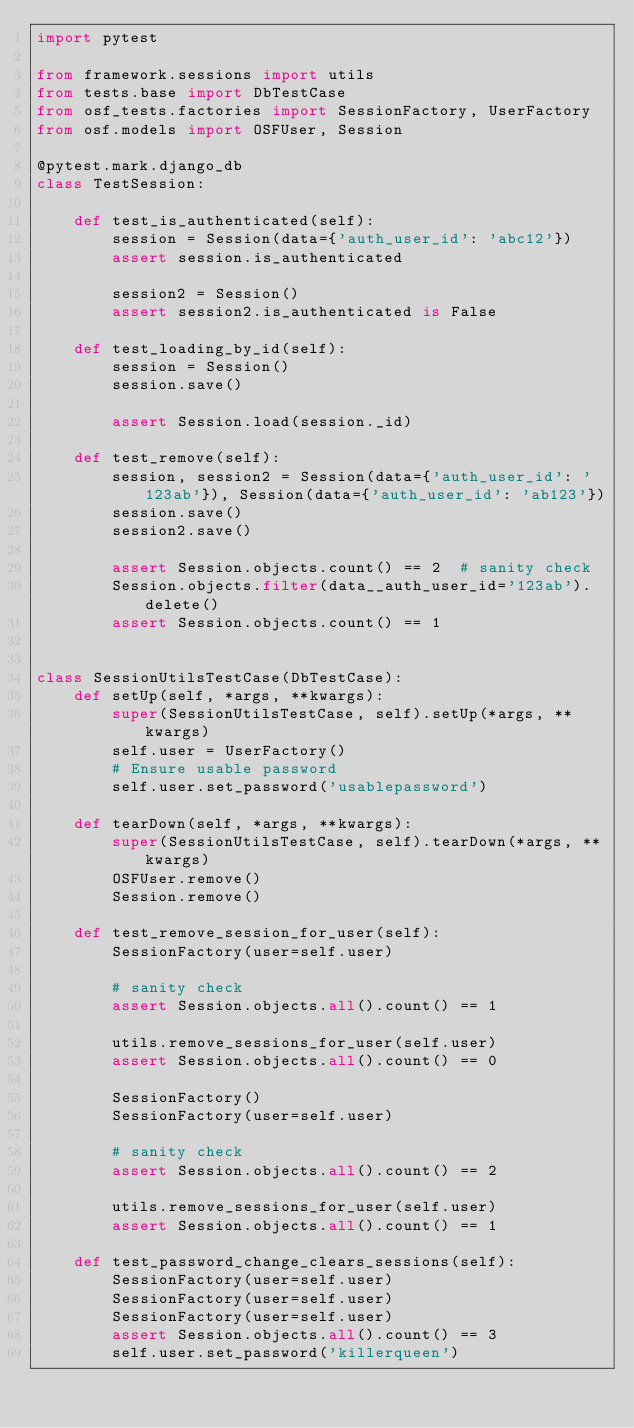<code> <loc_0><loc_0><loc_500><loc_500><_Python_>import pytest

from framework.sessions import utils
from tests.base import DbTestCase
from osf_tests.factories import SessionFactory, UserFactory
from osf.models import OSFUser, Session

@pytest.mark.django_db
class TestSession:

    def test_is_authenticated(self):
        session = Session(data={'auth_user_id': 'abc12'})
        assert session.is_authenticated

        session2 = Session()
        assert session2.is_authenticated is False

    def test_loading_by_id(self):
        session = Session()
        session.save()

        assert Session.load(session._id)

    def test_remove(self):
        session, session2 = Session(data={'auth_user_id': '123ab'}), Session(data={'auth_user_id': 'ab123'})
        session.save()
        session2.save()

        assert Session.objects.count() == 2  # sanity check
        Session.objects.filter(data__auth_user_id='123ab').delete()
        assert Session.objects.count() == 1


class SessionUtilsTestCase(DbTestCase):
    def setUp(self, *args, **kwargs):
        super(SessionUtilsTestCase, self).setUp(*args, **kwargs)
        self.user = UserFactory()
        # Ensure usable password
        self.user.set_password('usablepassword')

    def tearDown(self, *args, **kwargs):
        super(SessionUtilsTestCase, self).tearDown(*args, **kwargs)
        OSFUser.remove()
        Session.remove()

    def test_remove_session_for_user(self):
        SessionFactory(user=self.user)

        # sanity check
        assert Session.objects.all().count() == 1

        utils.remove_sessions_for_user(self.user)
        assert Session.objects.all().count() == 0

        SessionFactory()
        SessionFactory(user=self.user)

        # sanity check
        assert Session.objects.all().count() == 2

        utils.remove_sessions_for_user(self.user)
        assert Session.objects.all().count() == 1

    def test_password_change_clears_sessions(self):
        SessionFactory(user=self.user)
        SessionFactory(user=self.user)
        SessionFactory(user=self.user)
        assert Session.objects.all().count() == 3
        self.user.set_password('killerqueen')</code> 